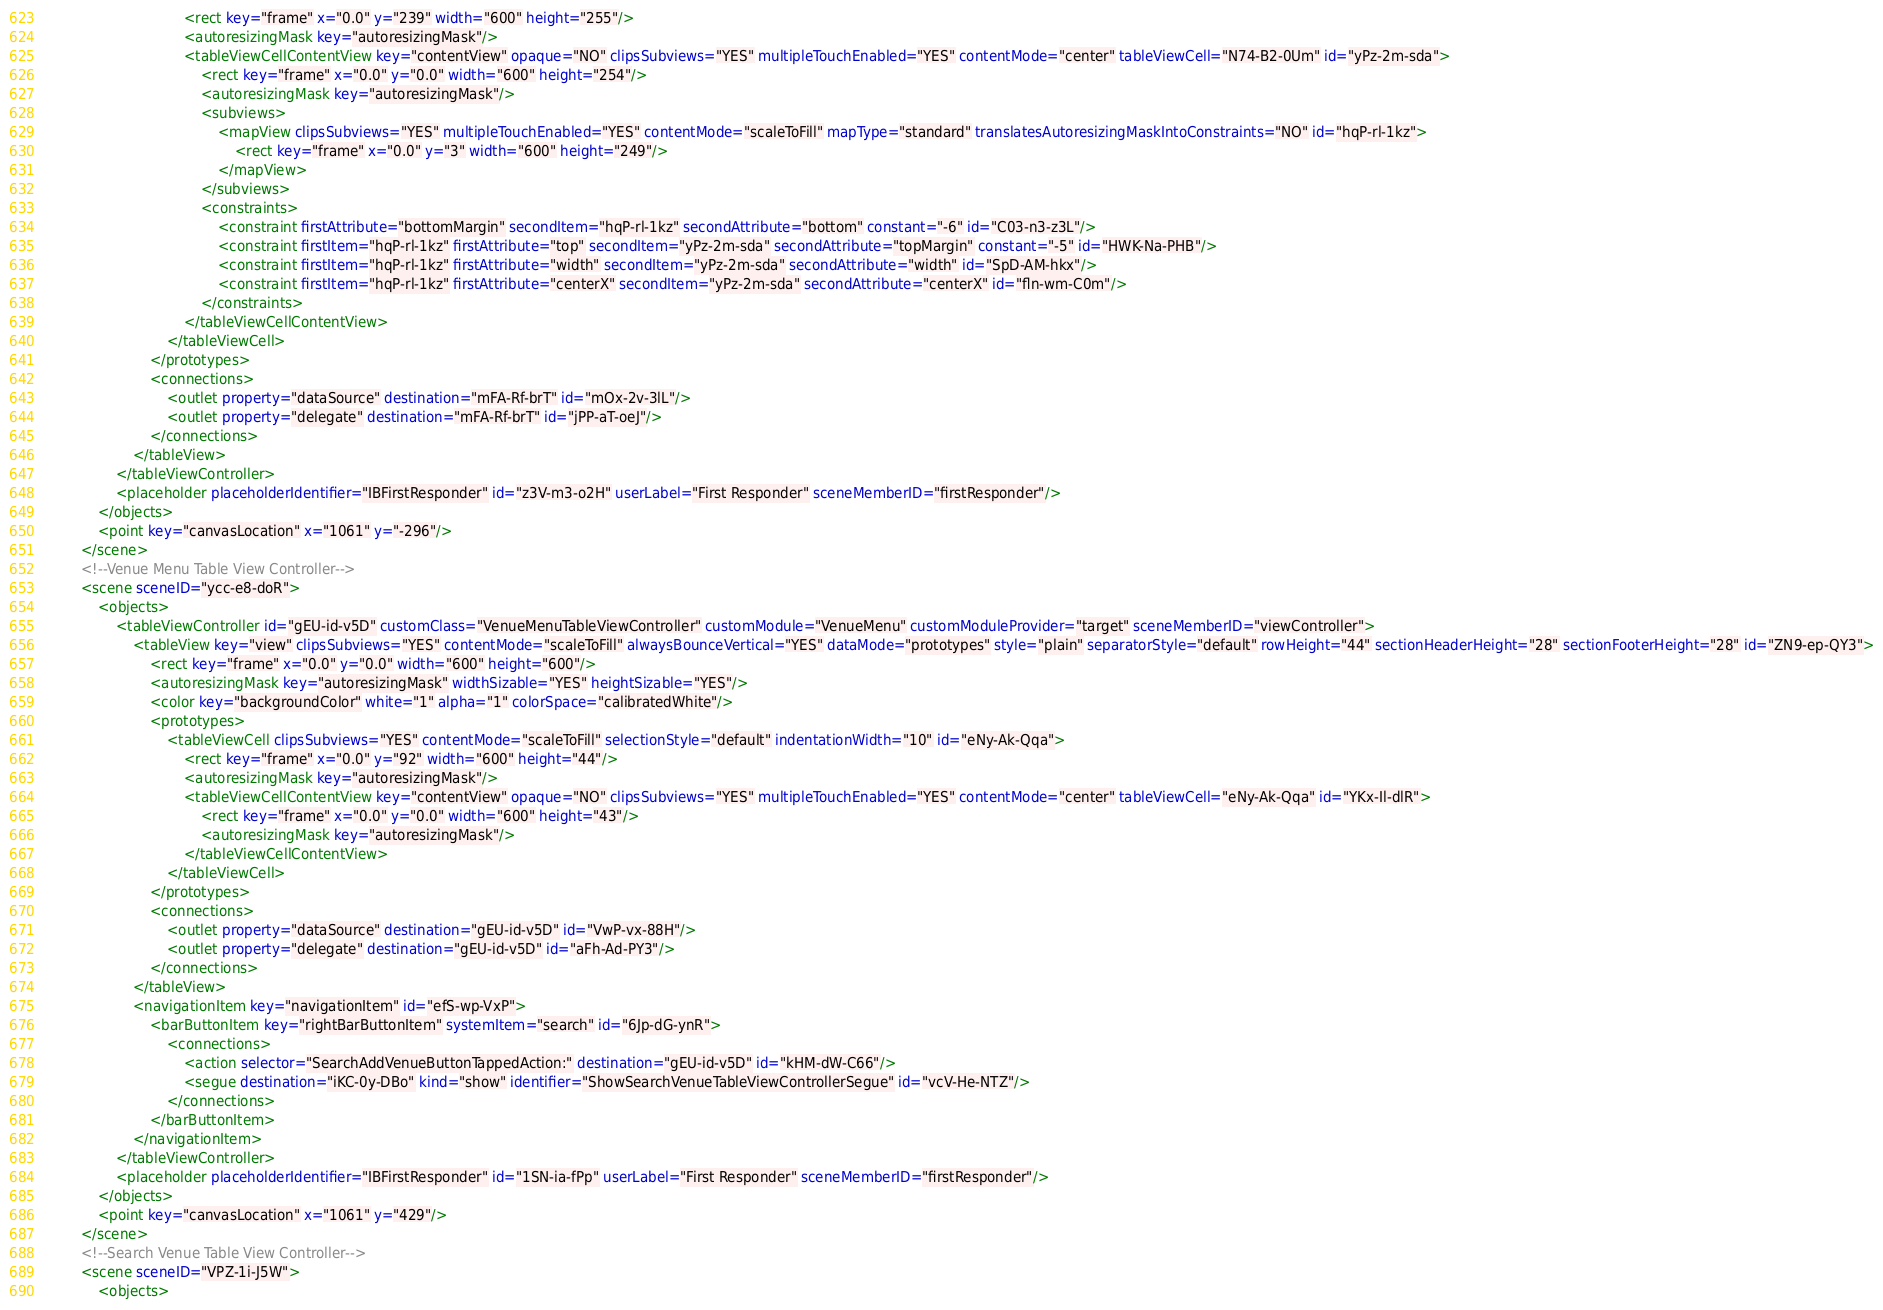Convert code to text. <code><loc_0><loc_0><loc_500><loc_500><_XML_>                                <rect key="frame" x="0.0" y="239" width="600" height="255"/>
                                <autoresizingMask key="autoresizingMask"/>
                                <tableViewCellContentView key="contentView" opaque="NO" clipsSubviews="YES" multipleTouchEnabled="YES" contentMode="center" tableViewCell="N74-B2-0Um" id="yPz-2m-sda">
                                    <rect key="frame" x="0.0" y="0.0" width="600" height="254"/>
                                    <autoresizingMask key="autoresizingMask"/>
                                    <subviews>
                                        <mapView clipsSubviews="YES" multipleTouchEnabled="YES" contentMode="scaleToFill" mapType="standard" translatesAutoresizingMaskIntoConstraints="NO" id="hqP-rl-1kz">
                                            <rect key="frame" x="0.0" y="3" width="600" height="249"/>
                                        </mapView>
                                    </subviews>
                                    <constraints>
                                        <constraint firstAttribute="bottomMargin" secondItem="hqP-rl-1kz" secondAttribute="bottom" constant="-6" id="C03-n3-z3L"/>
                                        <constraint firstItem="hqP-rl-1kz" firstAttribute="top" secondItem="yPz-2m-sda" secondAttribute="topMargin" constant="-5" id="HWK-Na-PHB"/>
                                        <constraint firstItem="hqP-rl-1kz" firstAttribute="width" secondItem="yPz-2m-sda" secondAttribute="width" id="SpD-AM-hkx"/>
                                        <constraint firstItem="hqP-rl-1kz" firstAttribute="centerX" secondItem="yPz-2m-sda" secondAttribute="centerX" id="fln-wm-C0m"/>
                                    </constraints>
                                </tableViewCellContentView>
                            </tableViewCell>
                        </prototypes>
                        <connections>
                            <outlet property="dataSource" destination="mFA-Rf-brT" id="mOx-2v-3lL"/>
                            <outlet property="delegate" destination="mFA-Rf-brT" id="jPP-aT-oeJ"/>
                        </connections>
                    </tableView>
                </tableViewController>
                <placeholder placeholderIdentifier="IBFirstResponder" id="z3V-m3-o2H" userLabel="First Responder" sceneMemberID="firstResponder"/>
            </objects>
            <point key="canvasLocation" x="1061" y="-296"/>
        </scene>
        <!--Venue Menu Table View Controller-->
        <scene sceneID="ycc-e8-doR">
            <objects>
                <tableViewController id="gEU-id-v5D" customClass="VenueMenuTableViewController" customModule="VenueMenu" customModuleProvider="target" sceneMemberID="viewController">
                    <tableView key="view" clipsSubviews="YES" contentMode="scaleToFill" alwaysBounceVertical="YES" dataMode="prototypes" style="plain" separatorStyle="default" rowHeight="44" sectionHeaderHeight="28" sectionFooterHeight="28" id="ZN9-ep-QY3">
                        <rect key="frame" x="0.0" y="0.0" width="600" height="600"/>
                        <autoresizingMask key="autoresizingMask" widthSizable="YES" heightSizable="YES"/>
                        <color key="backgroundColor" white="1" alpha="1" colorSpace="calibratedWhite"/>
                        <prototypes>
                            <tableViewCell clipsSubviews="YES" contentMode="scaleToFill" selectionStyle="default" indentationWidth="10" id="eNy-Ak-Qqa">
                                <rect key="frame" x="0.0" y="92" width="600" height="44"/>
                                <autoresizingMask key="autoresizingMask"/>
                                <tableViewCellContentView key="contentView" opaque="NO" clipsSubviews="YES" multipleTouchEnabled="YES" contentMode="center" tableViewCell="eNy-Ak-Qqa" id="YKx-Il-dlR">
                                    <rect key="frame" x="0.0" y="0.0" width="600" height="43"/>
                                    <autoresizingMask key="autoresizingMask"/>
                                </tableViewCellContentView>
                            </tableViewCell>
                        </prototypes>
                        <connections>
                            <outlet property="dataSource" destination="gEU-id-v5D" id="VwP-vx-88H"/>
                            <outlet property="delegate" destination="gEU-id-v5D" id="aFh-Ad-PY3"/>
                        </connections>
                    </tableView>
                    <navigationItem key="navigationItem" id="efS-wp-VxP">
                        <barButtonItem key="rightBarButtonItem" systemItem="search" id="6Jp-dG-ynR">
                            <connections>
                                <action selector="SearchAddVenueButtonTappedAction:" destination="gEU-id-v5D" id="kHM-dW-C66"/>
                                <segue destination="iKC-0y-DBo" kind="show" identifier="ShowSearchVenueTableViewControllerSegue" id="vcV-He-NTZ"/>
                            </connections>
                        </barButtonItem>
                    </navigationItem>
                </tableViewController>
                <placeholder placeholderIdentifier="IBFirstResponder" id="1SN-ia-fPp" userLabel="First Responder" sceneMemberID="firstResponder"/>
            </objects>
            <point key="canvasLocation" x="1061" y="429"/>
        </scene>
        <!--Search Venue Table View Controller-->
        <scene sceneID="VPZ-1i-J5W">
            <objects></code> 